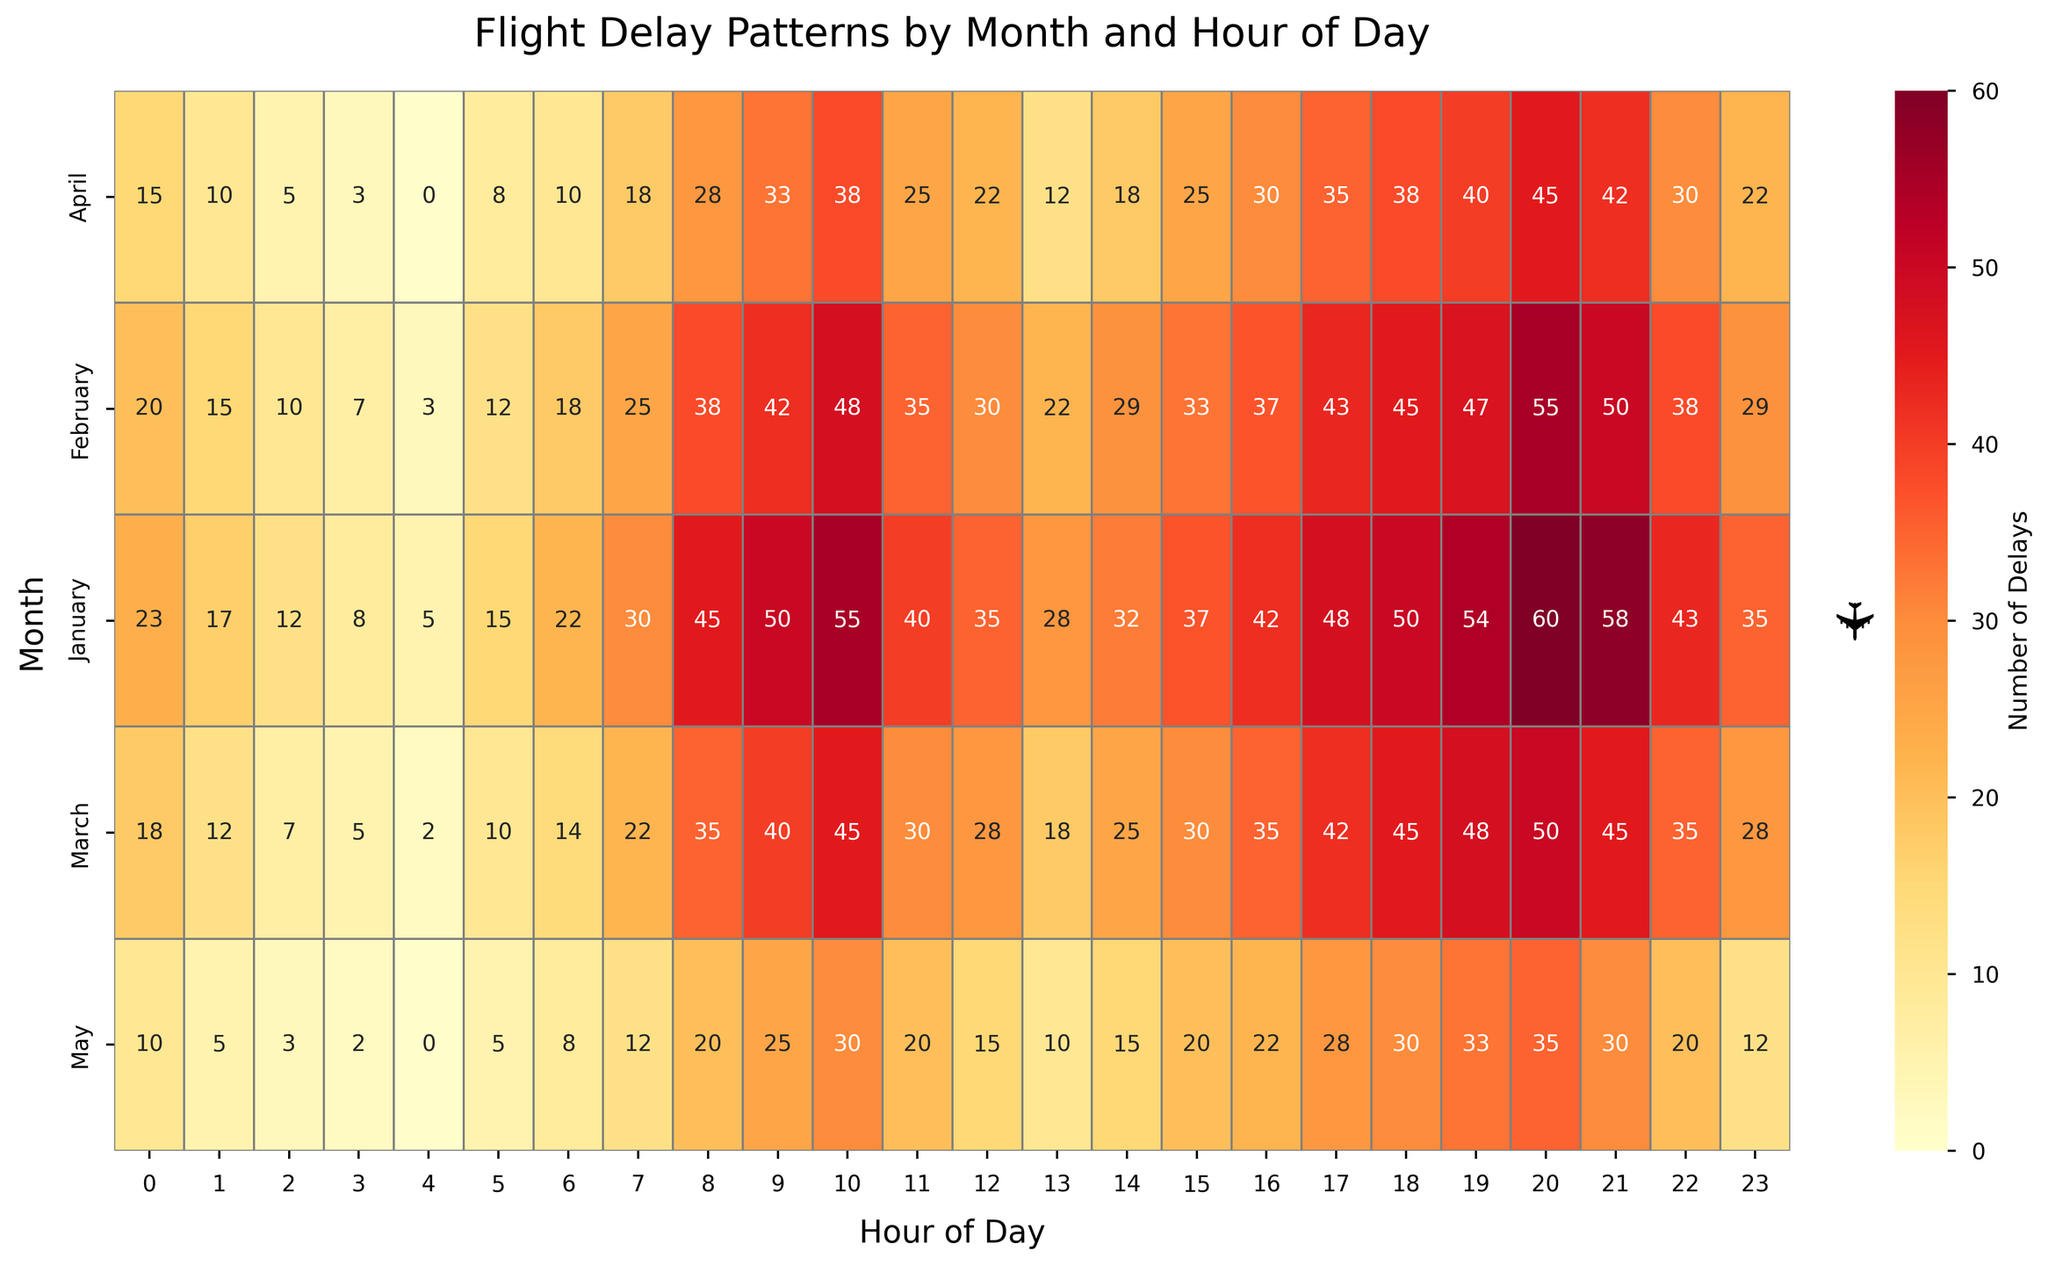What is the title of the figure? The title is displayed at the top of the figure, summarizing the data being visualized. It reads "Flight Delay Patterns by Month and Hour of Day."
Answer: Flight Delay Patterns by Month and Hour of Day What does the color intensity represent in the heatmap? The color intensity varies from light yellow to dark red. According to the color bar, it represents the number of flight delays, with lighter colors indicating fewer delays and darker colors indicating more delays.
Answer: Number of delays During which month and hour are the highest number of delays observed? By examining the heatmap, the darkest cell indicates the highest number of delays. This cell is located at the intersection of January and 21:00 hours. The annotation confirms 60 delays.
Answer: January at 21:00 Which hour of the day experiences the least delays in January? Find the lightest cell in January row and check its corresponding hour. The lightest cell corresponds to 04:00 hours with 5 delays.
Answer: 04:00 How do the delays in April at 10:00 hours compare to those in May at the same hour? Locate the cells for April at 10:00 and May at 10:00. April has a cell with 38 delays, while May has a cell with 30 delays. Therefore, April has more delays than May at this hour.
Answer: More in April What is the total number of delays in February between 18:00 and 21:00 hours? Sum the values for February at 18:00 (45), 19:00 (47), 20:00 (55), and 21:00 (50). Total delays = 45 + 47 + 55 + 50 = 197.
Answer: 197 On average, how many delays occur at 9:00 hours across all months? Find the values at 9:00 for each month and calculate the average. Delays at 9:00 are January (50), February (42), March (40), April (33), and May (25). Average = (50 + 42 + 40 + 33 + 25) / 5 = 38.
Answer: 38 Do flight delays tend to increase or decrease as the day progresses? Examine the color transitions across the hours of the day for most months. Generally, the color intensity increases, suggesting more delays in the evening compared to early hours.
Answer: Increase Which month shows the most consistent pattern of delays throughout the day? By observing uniform color intensity across different hours of the same month, March shows a more consistent pattern with no large variations in color intensity.
Answer: March During which hour in February are delays closest to the monthly average of February? First, calculate the monthly average for February. Then find the hour closest to this value. February delays: 20, 15, 10, 7, 3, 12, 18, 25, 38, 42, 48, 35, 30, 22, 29, 33, 37, 43, 45, 47, 55, 50, 38, 29. Average = sum/24 = 35. Closest value is 35 at 11:00 hours.
Answer: 11:00 